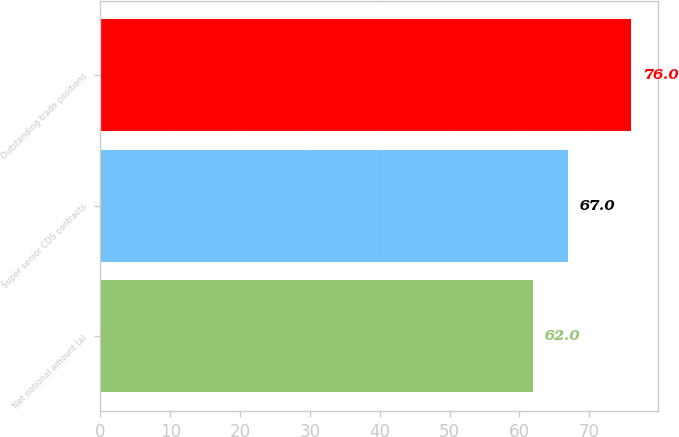Convert chart. <chart><loc_0><loc_0><loc_500><loc_500><bar_chart><fcel>Net notional amount (a)<fcel>Super senior CDS contracts<fcel>Outstanding trade positions<nl><fcel>62<fcel>67<fcel>76<nl></chart> 